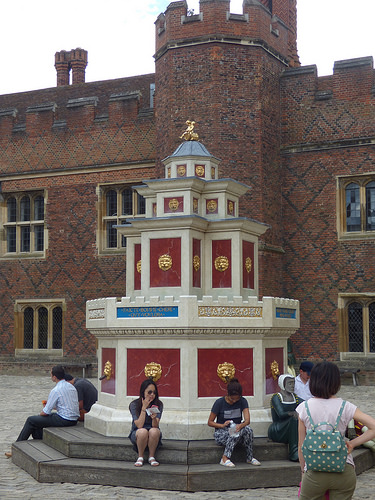<image>
Can you confirm if the woman is in front of the building? Yes. The woman is positioned in front of the building, appearing closer to the camera viewpoint. 